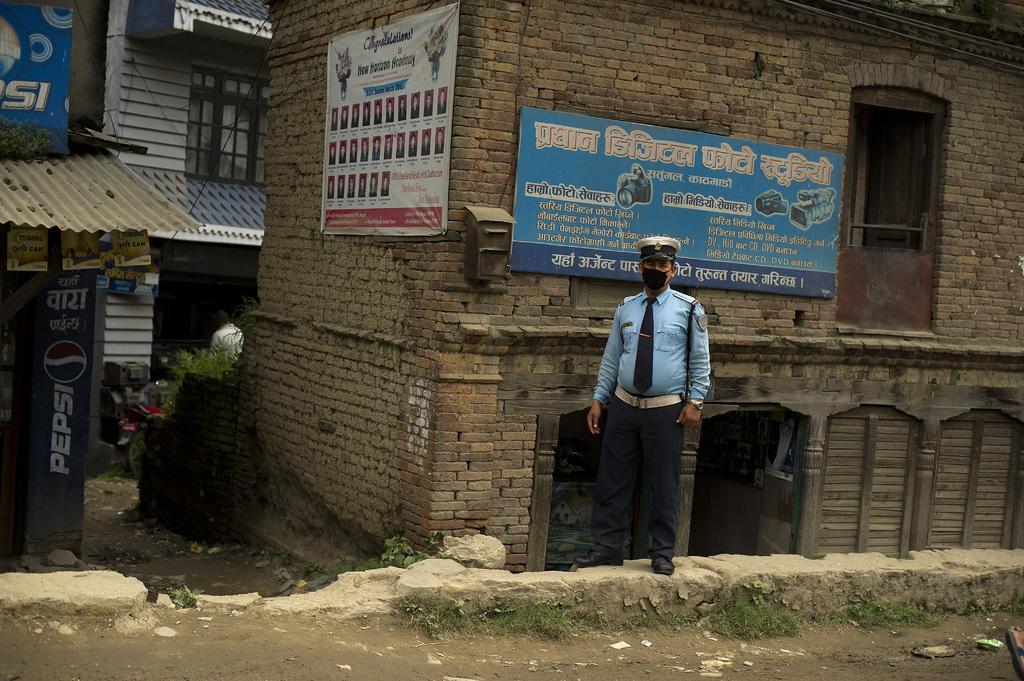Please provide a concise description of this image. In this image I can see a man standing. In the background, I can see the houses with some text written on it. 